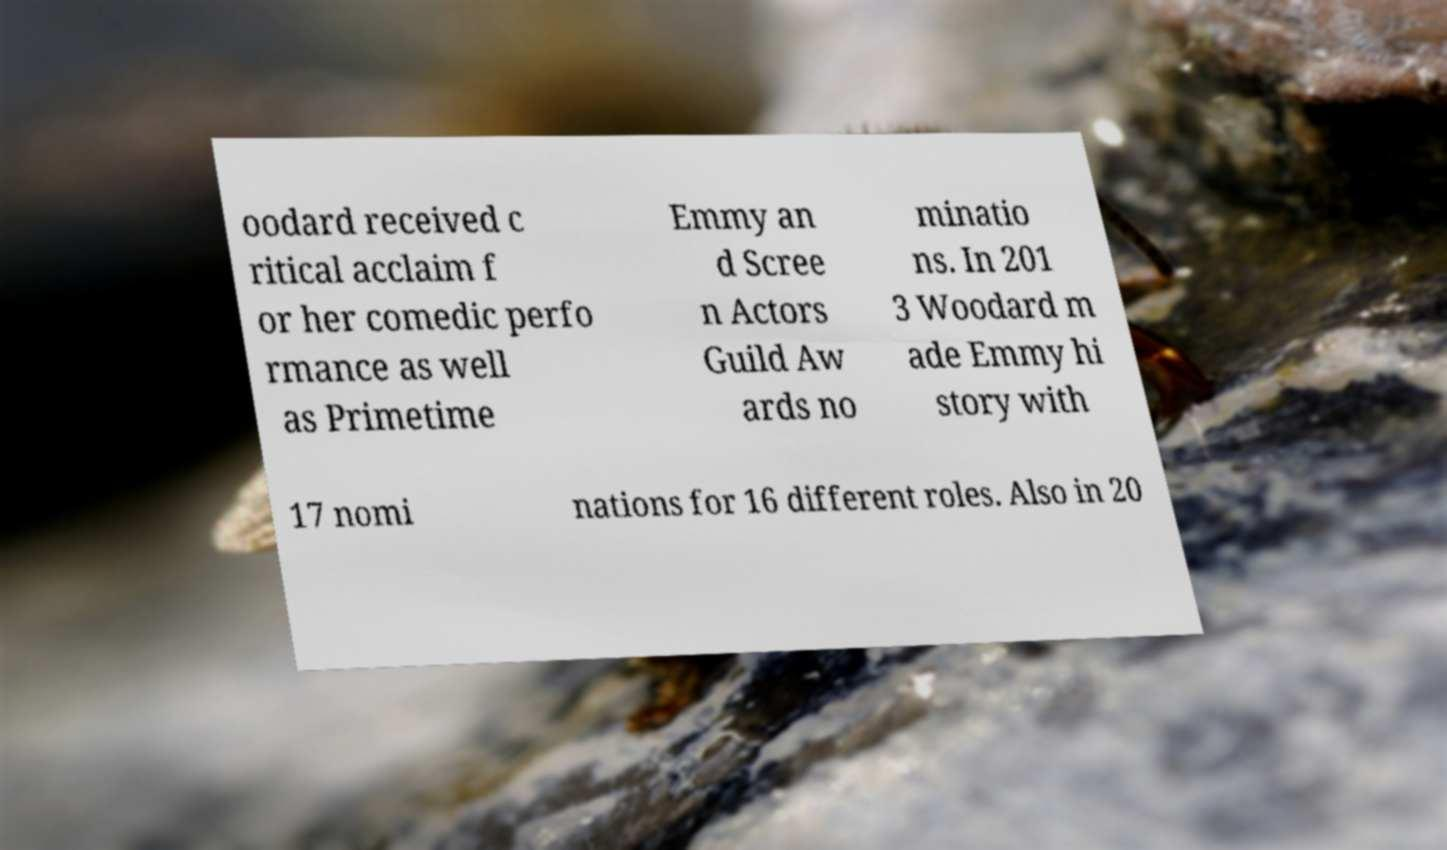There's text embedded in this image that I need extracted. Can you transcribe it verbatim? oodard received c ritical acclaim f or her comedic perfo rmance as well as Primetime Emmy an d Scree n Actors Guild Aw ards no minatio ns. In 201 3 Woodard m ade Emmy hi story with 17 nomi nations for 16 different roles. Also in 20 